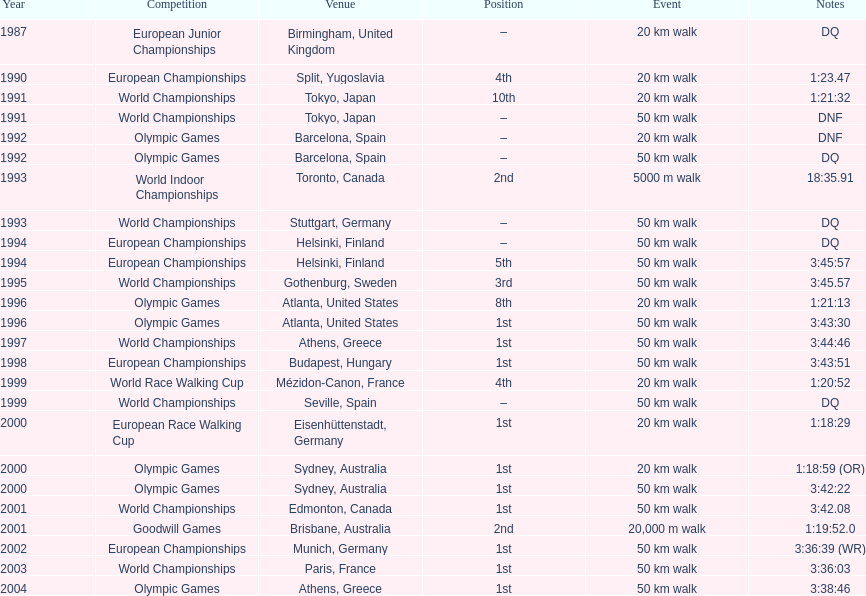Parse the full table. {'header': ['Year', 'Competition', 'Venue', 'Position', 'Event', 'Notes'], 'rows': [['1987', 'European Junior Championships', 'Birmingham, United Kingdom', '–', '20\xa0km walk', 'DQ'], ['1990', 'European Championships', 'Split, Yugoslavia', '4th', '20\xa0km walk', '1:23.47'], ['1991', 'World Championships', 'Tokyo, Japan', '10th', '20\xa0km walk', '1:21:32'], ['1991', 'World Championships', 'Tokyo, Japan', '–', '50\xa0km walk', 'DNF'], ['1992', 'Olympic Games', 'Barcelona, Spain', '–', '20\xa0km walk', 'DNF'], ['1992', 'Olympic Games', 'Barcelona, Spain', '–', '50\xa0km walk', 'DQ'], ['1993', 'World Indoor Championships', 'Toronto, Canada', '2nd', '5000 m walk', '18:35.91'], ['1993', 'World Championships', 'Stuttgart, Germany', '–', '50\xa0km walk', 'DQ'], ['1994', 'European Championships', 'Helsinki, Finland', '–', '50\xa0km walk', 'DQ'], ['1994', 'European Championships', 'Helsinki, Finland', '5th', '50\xa0km walk', '3:45:57'], ['1995', 'World Championships', 'Gothenburg, Sweden', '3rd', '50\xa0km walk', '3:45.57'], ['1996', 'Olympic Games', 'Atlanta, United States', '8th', '20\xa0km walk', '1:21:13'], ['1996', 'Olympic Games', 'Atlanta, United States', '1st', '50\xa0km walk', '3:43:30'], ['1997', 'World Championships', 'Athens, Greece', '1st', '50\xa0km walk', '3:44:46'], ['1998', 'European Championships', 'Budapest, Hungary', '1st', '50\xa0km walk', '3:43:51'], ['1999', 'World Race Walking Cup', 'Mézidon-Canon, France', '4th', '20\xa0km walk', '1:20:52'], ['1999', 'World Championships', 'Seville, Spain', '–', '50\xa0km walk', 'DQ'], ['2000', 'European Race Walking Cup', 'Eisenhüttenstadt, Germany', '1st', '20\xa0km walk', '1:18:29'], ['2000', 'Olympic Games', 'Sydney, Australia', '1st', '20\xa0km walk', '1:18:59 (OR)'], ['2000', 'Olympic Games', 'Sydney, Australia', '1st', '50\xa0km walk', '3:42:22'], ['2001', 'World Championships', 'Edmonton, Canada', '1st', '50\xa0km walk', '3:42.08'], ['2001', 'Goodwill Games', 'Brisbane, Australia', '2nd', '20,000 m walk', '1:19:52.0'], ['2002', 'European Championships', 'Munich, Germany', '1st', '50\xa0km walk', '3:36:39 (WR)'], ['2003', 'World Championships', 'Paris, France', '1st', '50\xa0km walk', '3:36:03'], ['2004', 'Olympic Games', 'Athens, Greece', '1st', '50\xa0km walk', '3:38:46']]} What was the name of the competition that took place before the olympic games in 1996? World Championships. 